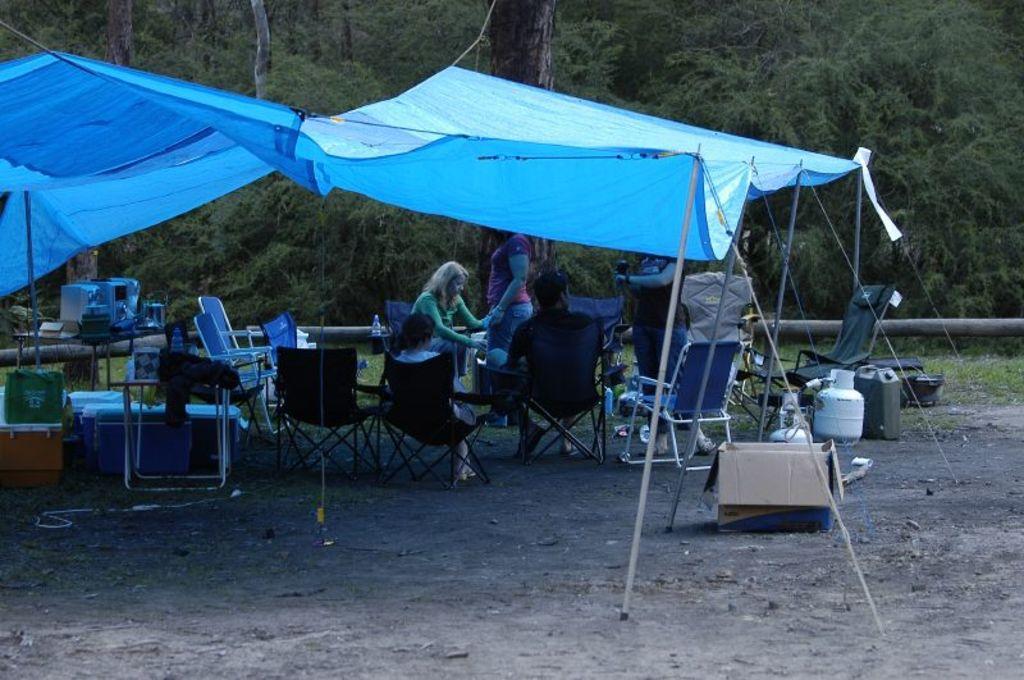Please provide a concise description of this image. In this image there are tables, chairs, cardboard box, water cans, water bottles, three persons sitting on the chairs , and two persons standing under the tent, and at the background there is grass, trees. 